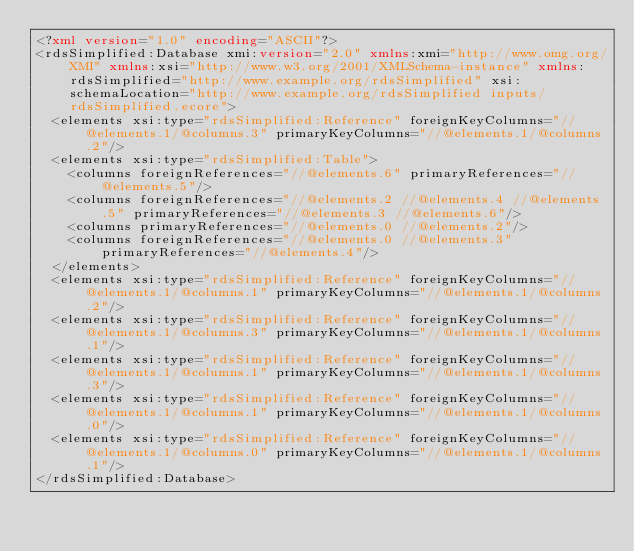<code> <loc_0><loc_0><loc_500><loc_500><_XML_><?xml version="1.0" encoding="ASCII"?>
<rdsSimplified:Database xmi:version="2.0" xmlns:xmi="http://www.omg.org/XMI" xmlns:xsi="http://www.w3.org/2001/XMLSchema-instance" xmlns:rdsSimplified="http://www.example.org/rdsSimplified" xsi:schemaLocation="http://www.example.org/rdsSimplified inputs/rdsSimplified.ecore">
  <elements xsi:type="rdsSimplified:Reference" foreignKeyColumns="//@elements.1/@columns.3" primaryKeyColumns="//@elements.1/@columns.2"/>
  <elements xsi:type="rdsSimplified:Table">
    <columns foreignReferences="//@elements.6" primaryReferences="//@elements.5"/>
    <columns foreignReferences="//@elements.2 //@elements.4 //@elements.5" primaryReferences="//@elements.3 //@elements.6"/>
    <columns primaryReferences="//@elements.0 //@elements.2"/>
    <columns foreignReferences="//@elements.0 //@elements.3" primaryReferences="//@elements.4"/>
  </elements>
  <elements xsi:type="rdsSimplified:Reference" foreignKeyColumns="//@elements.1/@columns.1" primaryKeyColumns="//@elements.1/@columns.2"/>
  <elements xsi:type="rdsSimplified:Reference" foreignKeyColumns="//@elements.1/@columns.3" primaryKeyColumns="//@elements.1/@columns.1"/>
  <elements xsi:type="rdsSimplified:Reference" foreignKeyColumns="//@elements.1/@columns.1" primaryKeyColumns="//@elements.1/@columns.3"/>
  <elements xsi:type="rdsSimplified:Reference" foreignKeyColumns="//@elements.1/@columns.1" primaryKeyColumns="//@elements.1/@columns.0"/>
  <elements xsi:type="rdsSimplified:Reference" foreignKeyColumns="//@elements.1/@columns.0" primaryKeyColumns="//@elements.1/@columns.1"/>
</rdsSimplified:Database>
</code> 